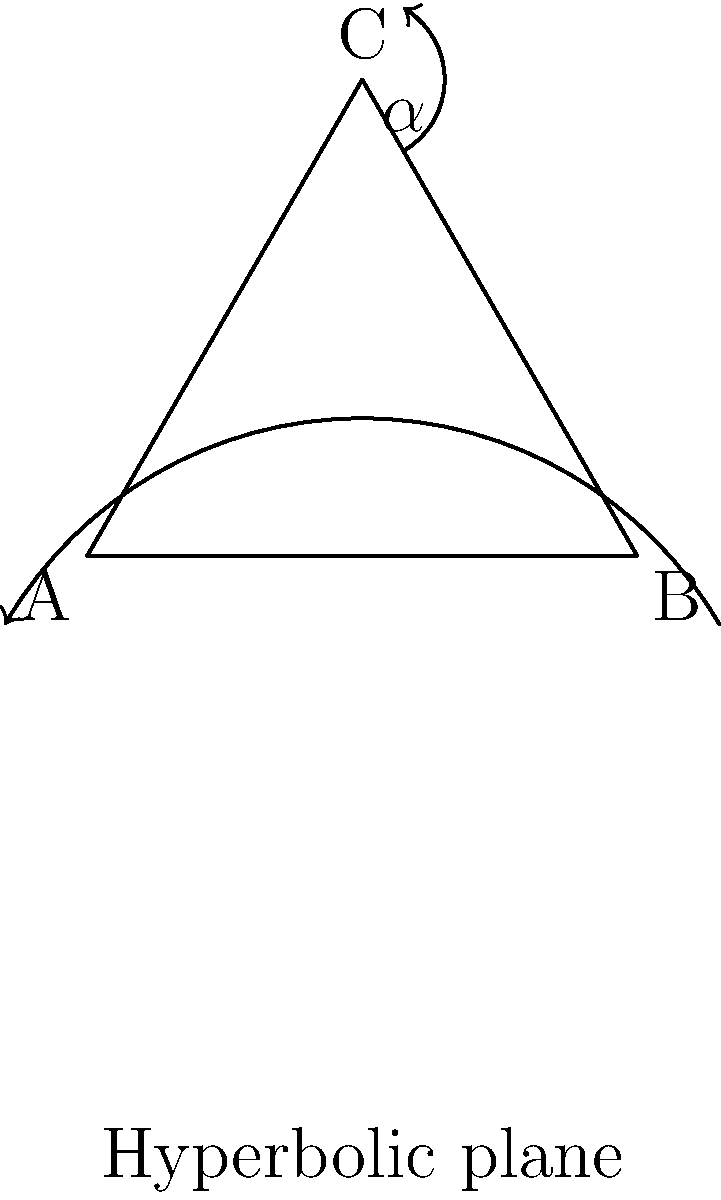In the development of non-Euclidean geometry, which historical figure's work on parallel postulates led to the discovery of hyperbolic geometry, challenging the long-held belief in Euclidean geometry's absolute truth and paving the way for new scientific understanding? To answer this question, let's consider the historical development of non-Euclidean geometry:

1. Euclid's Elements (c. 300 BCE) laid the foundation for geometry, including the parallel postulate.

2. For centuries, mathematicians attempted to prove the parallel postulate from Euclid's other axioms.

3. In the 18th and early 19th centuries, mathematicians began to consider alternatives to the parallel postulate.

4. János Bolyai (1802-1860) and Nikolai Lobachevsky (1792-1856) independently developed hyperbolic geometry.

5. However, it was the work of Carl Friedrich Gauss (1777-1855) that truly pioneered the field:
   - Gauss had been working on the problem of parallel lines since his youth.
   - He developed the foundations of hyperbolic geometry but didn't publish his findings.
   - Gauss's unpublished work predated both Bolyai and Lobachevsky.

6. Gauss's work on differential geometry and his concept of intrinsic curvature laid the groundwork for understanding non-Euclidean geometries.

7. This development challenged the notion that Euclidean geometry was the only "true" geometry, opening up new possibilities in mathematics and physics.

8. The discovery of non-Euclidean geometries had profound implications:
   - It showed that mathematical systems could be logically consistent without corresponding to physical reality.
   - It paved the way for Einstein's theory of general relativity, which uses non-Euclidean geometry to describe spacetime.

While Bolyai and Lobachevsky are often credited with the discovery of hyperbolic geometry, Gauss's earlier, unpublished work and his broader influence on the field make him the key figure in this development.
Answer: Carl Friedrich Gauss 